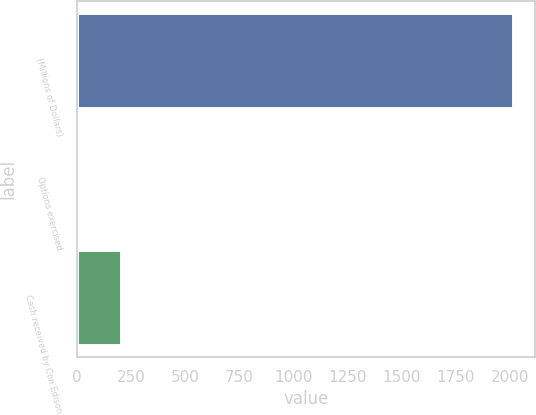Convert chart to OTSL. <chart><loc_0><loc_0><loc_500><loc_500><bar_chart><fcel>(Millions of Dollars)<fcel>Options exercised<fcel>Cash received by Con Edison<nl><fcel>2015<fcel>3<fcel>204.2<nl></chart> 